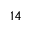<formula> <loc_0><loc_0><loc_500><loc_500>_ { 1 } 4</formula> 